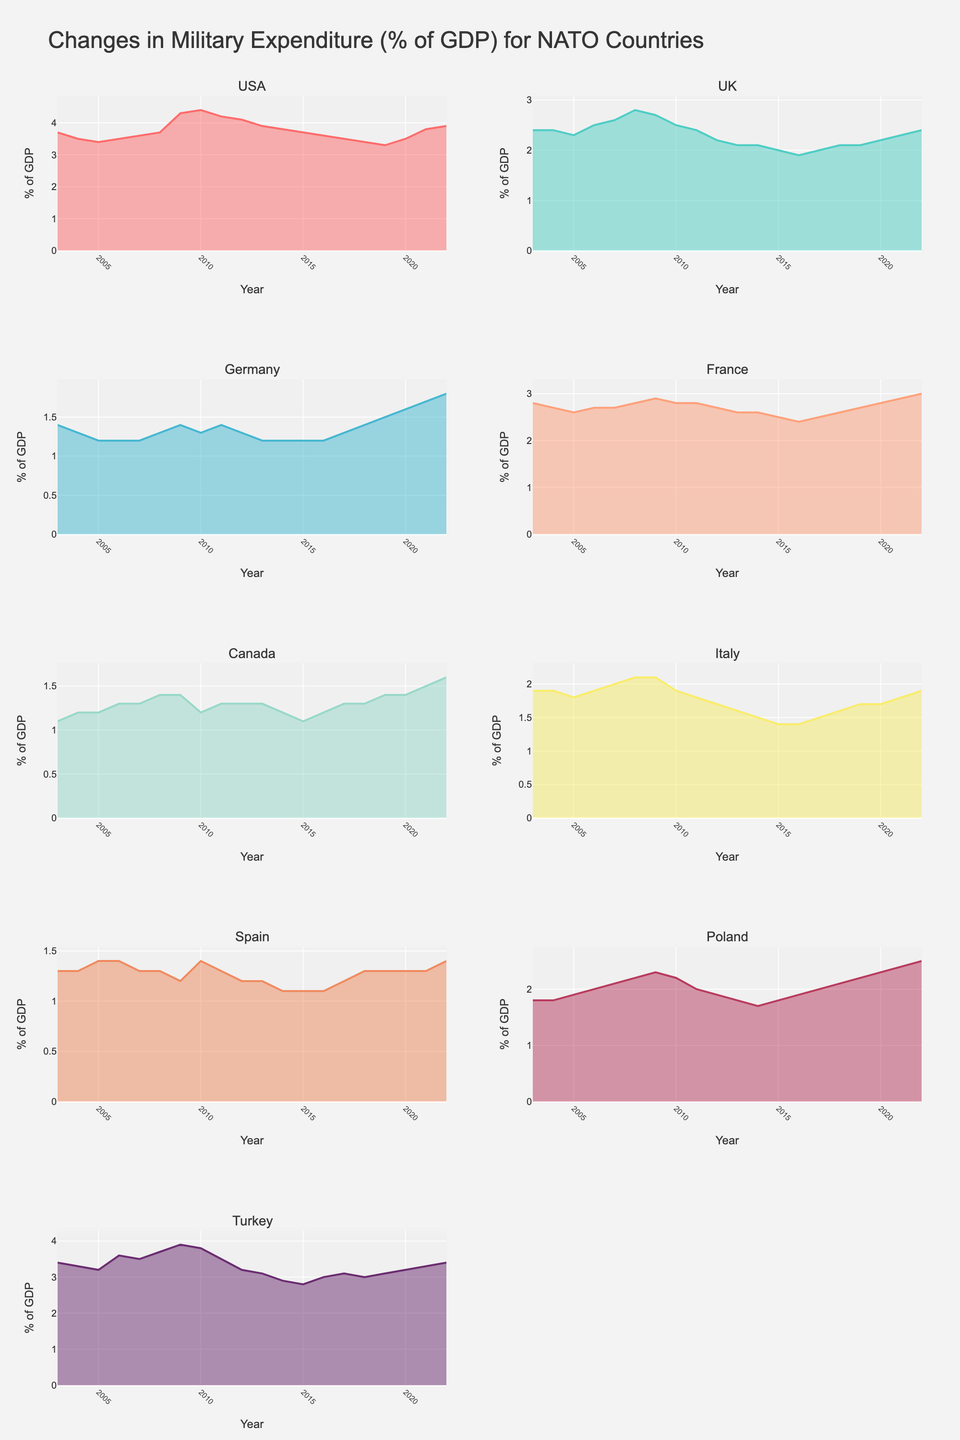What is the overall trend in the USA's military expenditure as a percentage of GDP over the past 20 years? The graph shows that the USA's military expenditure as a percentage of GDP generally decreases from 2003 to around 2014, followed by a slight decline and then stabilizes around 3.8% to 3.9% from 2021 to 2022.
Answer: Decreasing initially, stabilizing later Which NATO country had the highest percentage of GDP spent on military expenditure in 2022? Looking at the charts for each country in 2022, the USA had the highest percentage with 3.9% of its GDP spent on military expenditure.
Answer: USA In which year did Germany have the lowest percentage of GDP spent on military expenditure? By inspecting Germany's chart, the lowest percentage was in 2005 when it spent 1.2% of its GDP on military expenditure.
Answer: 2005 How does the trend in military expenditure for France compare to that of Italy from 2003 to 2022? France's military expenditure remains relatively stable with slight increases or decreases around 2.4% to 3.0% of GDP. Italy's expenditure shows a more apparent decrease from around 1.9% to 1.4% of GDP. France's trend is more stable compared to Italy's decreasing trend.
Answer: France is stable, Italy decreases During which years did the UK's military expenditure as a percentage of GDP fall below 2.2%? By examining the UK’s chart, the military expenditure fell below 2.2% from 2012 to 2016.
Answer: 2012 to 2016 Which country had the most significant increase in military expenditure as a percentage of GDP from 2015 to 2016? Comparing the charts of different countries between 2015 and 2016, Turkey shows the most significant increase, from approximately 2.8% to 3.0% of GDP.
Answer: Turkey What was the trend in military expenditure for Poland between 2003 and 2022? Poland's military expenditure starts around 1.8% in 2003, increases gradually, reaching around 2.5% by 2022.
Answer: Gradually increasing In which year did Canada spend the least percentage of its GDP on military expenditure? Canada's chart shows the lowest percentage spent was in 2005, at 1.2% of its GDP.
Answer: 2005 How does the military expenditure trend of Spain compare to Turkey's from 2003 to 2022? Spain's military spending generally decreased from 2003 to 2015 and then stabilized around 1.1% to 1.4%. In contrast, Turkey had a slightly fluctuating trend but generally increased from around 3.4% to 3.4% during the same period.
Answer: Spain decreases then stabilizes, Turkey fluctuates and increases Which country shows a continuous decrease in its military expenditure percentage of GDP from 2003 to 2015? Germany shows a continuous decrease in its military expenditure percentage of GDP from 2003 to 2015, based on its steadily descending line in the area chart.
Answer: Germany 